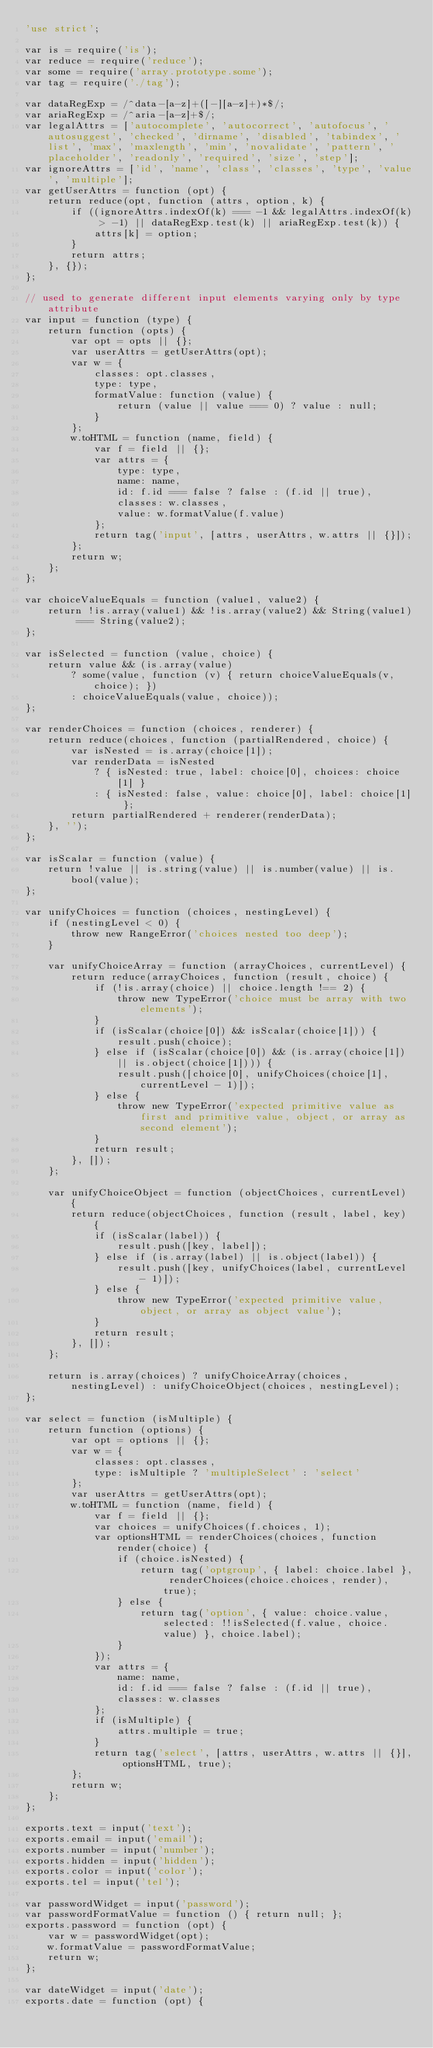Convert code to text. <code><loc_0><loc_0><loc_500><loc_500><_JavaScript_>'use strict';

var is = require('is');
var reduce = require('reduce');
var some = require('array.prototype.some');
var tag = require('./tag');

var dataRegExp = /^data-[a-z]+([-][a-z]+)*$/;
var ariaRegExp = /^aria-[a-z]+$/;
var legalAttrs = ['autocomplete', 'autocorrect', 'autofocus', 'autosuggest', 'checked', 'dirname', 'disabled', 'tabindex', 'list', 'max', 'maxlength', 'min', 'novalidate', 'pattern', 'placeholder', 'readonly', 'required', 'size', 'step'];
var ignoreAttrs = ['id', 'name', 'class', 'classes', 'type', 'value', 'multiple'];
var getUserAttrs = function (opt) {
    return reduce(opt, function (attrs, option, k) {
        if ((ignoreAttrs.indexOf(k) === -1 && legalAttrs.indexOf(k) > -1) || dataRegExp.test(k) || ariaRegExp.test(k)) {
            attrs[k] = option;
        }
        return attrs;
    }, {});
};

// used to generate different input elements varying only by type attribute
var input = function (type) {
    return function (opts) {
        var opt = opts || {};
        var userAttrs = getUserAttrs(opt);
        var w = {
            classes: opt.classes,
            type: type,
            formatValue: function (value) {
                return (value || value === 0) ? value : null;
            }
        };
        w.toHTML = function (name, field) {
            var f = field || {};
            var attrs = {
                type: type,
                name: name,
                id: f.id === false ? false : (f.id || true),
                classes: w.classes,
                value: w.formatValue(f.value)
            };
            return tag('input', [attrs, userAttrs, w.attrs || {}]);
        };
        return w;
    };
};

var choiceValueEquals = function (value1, value2) {
    return !is.array(value1) && !is.array(value2) && String(value1) === String(value2);
};

var isSelected = function (value, choice) {
    return value && (is.array(value)
        ? some(value, function (v) { return choiceValueEquals(v, choice); })
        : choiceValueEquals(value, choice));
};

var renderChoices = function (choices, renderer) {
    return reduce(choices, function (partialRendered, choice) {
        var isNested = is.array(choice[1]);
        var renderData = isNested
            ? { isNested: true, label: choice[0], choices: choice[1] }
            : { isNested: false, value: choice[0], label: choice[1] };
        return partialRendered + renderer(renderData);
    }, '');
};

var isScalar = function (value) {
    return !value || is.string(value) || is.number(value) || is.bool(value);
};

var unifyChoices = function (choices, nestingLevel) {
    if (nestingLevel < 0) {
        throw new RangeError('choices nested too deep');
    }

    var unifyChoiceArray = function (arrayChoices, currentLevel) {
        return reduce(arrayChoices, function (result, choice) {
            if (!is.array(choice) || choice.length !== 2) {
                throw new TypeError('choice must be array with two elements');
            }
            if (isScalar(choice[0]) && isScalar(choice[1])) {
                result.push(choice);
            } else if (isScalar(choice[0]) && (is.array(choice[1]) || is.object(choice[1]))) {
                result.push([choice[0], unifyChoices(choice[1], currentLevel - 1)]);
            } else {
                throw new TypeError('expected primitive value as first and primitive value, object, or array as second element');
            }
            return result;
        }, []);
    };

    var unifyChoiceObject = function (objectChoices, currentLevel) {
        return reduce(objectChoices, function (result, label, key) {
            if (isScalar(label)) {
                result.push([key, label]);
            } else if (is.array(label) || is.object(label)) {
                result.push([key, unifyChoices(label, currentLevel - 1)]);
            } else {
                throw new TypeError('expected primitive value, object, or array as object value');
            }
            return result;
        }, []);
    };

    return is.array(choices) ? unifyChoiceArray(choices, nestingLevel) : unifyChoiceObject(choices, nestingLevel);
};

var select = function (isMultiple) {
    return function (options) {
        var opt = options || {};
        var w = {
            classes: opt.classes,
            type: isMultiple ? 'multipleSelect' : 'select'
        };
        var userAttrs = getUserAttrs(opt);
        w.toHTML = function (name, field) {
            var f = field || {};
            var choices = unifyChoices(f.choices, 1);
            var optionsHTML = renderChoices(choices, function render(choice) {
                if (choice.isNested) {
                    return tag('optgroup', { label: choice.label }, renderChoices(choice.choices, render), true);
                } else {
                    return tag('option', { value: choice.value, selected: !!isSelected(f.value, choice.value) }, choice.label);
                }
            });
            var attrs = {
                name: name,
                id: f.id === false ? false : (f.id || true),
                classes: w.classes
            };
            if (isMultiple) {
                attrs.multiple = true;
            }
            return tag('select', [attrs, userAttrs, w.attrs || {}], optionsHTML, true);
        };
        return w;
    };
};

exports.text = input('text');
exports.email = input('email');
exports.number = input('number');
exports.hidden = input('hidden');
exports.color = input('color');
exports.tel = input('tel');

var passwordWidget = input('password');
var passwordFormatValue = function () { return null; };
exports.password = function (opt) {
    var w = passwordWidget(opt);
    w.formatValue = passwordFormatValue;
    return w;
};

var dateWidget = input('date');
exports.date = function (opt) {</code> 